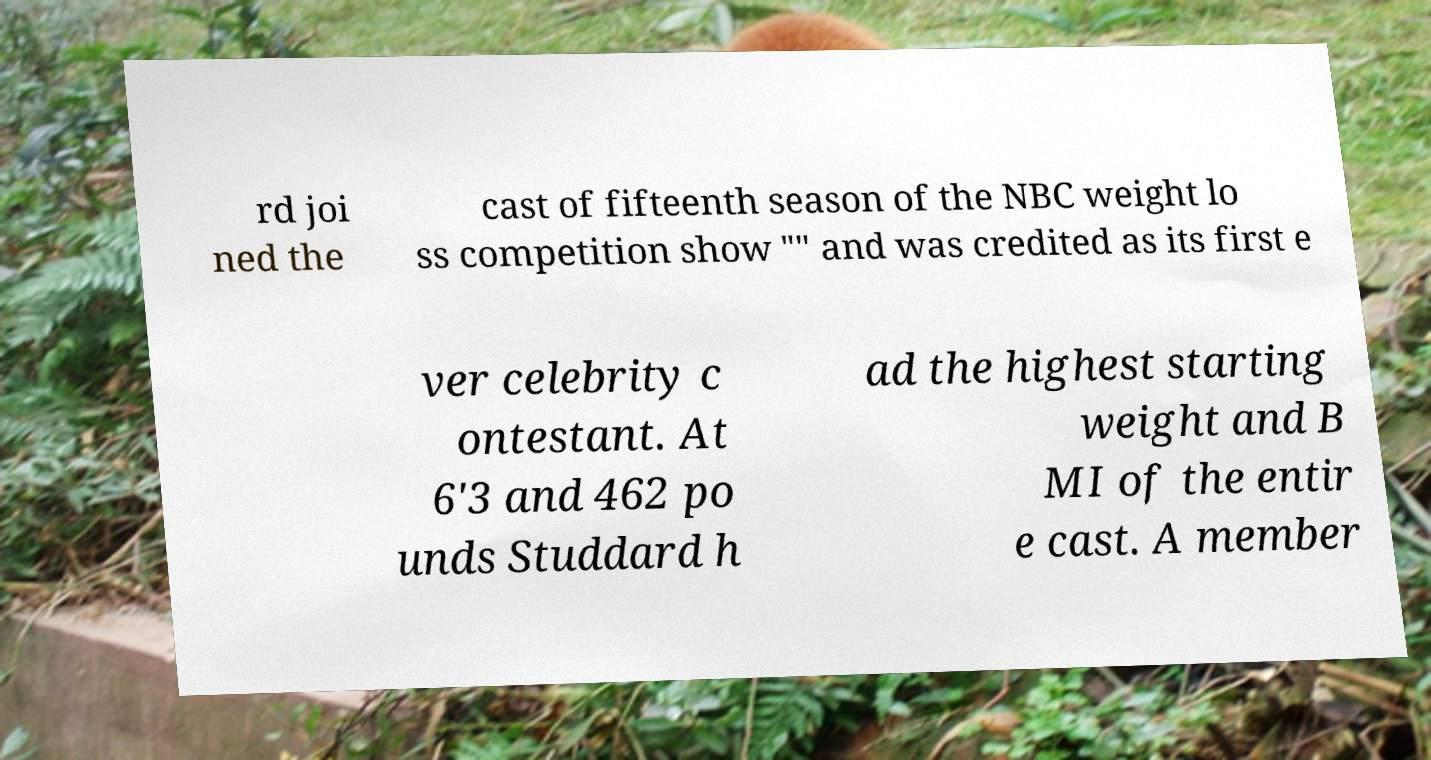Could you extract and type out the text from this image? rd joi ned the cast of fifteenth season of the NBC weight lo ss competition show "" and was credited as its first e ver celebrity c ontestant. At 6'3 and 462 po unds Studdard h ad the highest starting weight and B MI of the entir e cast. A member 